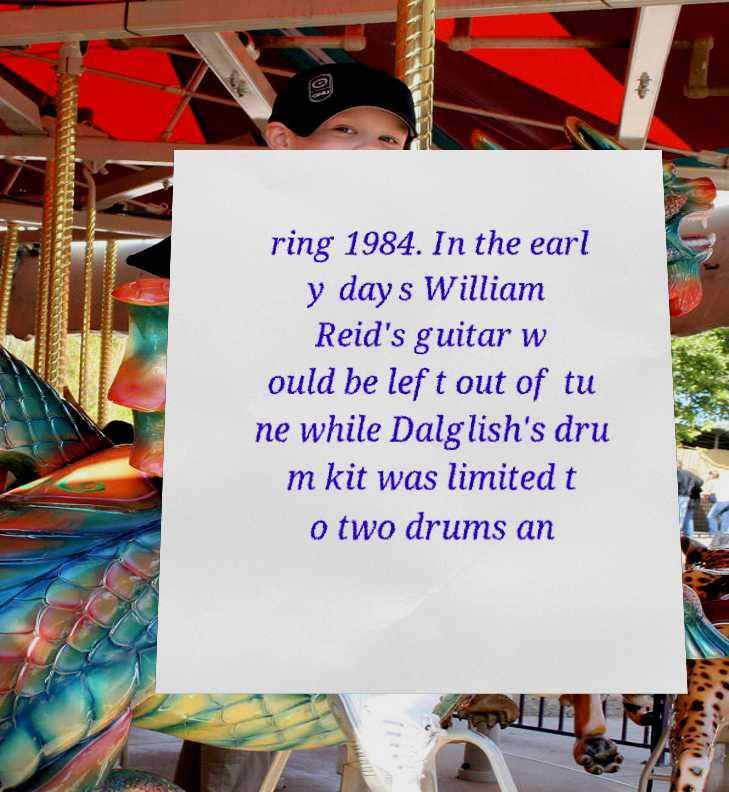I need the written content from this picture converted into text. Can you do that? ring 1984. In the earl y days William Reid's guitar w ould be left out of tu ne while Dalglish's dru m kit was limited t o two drums an 